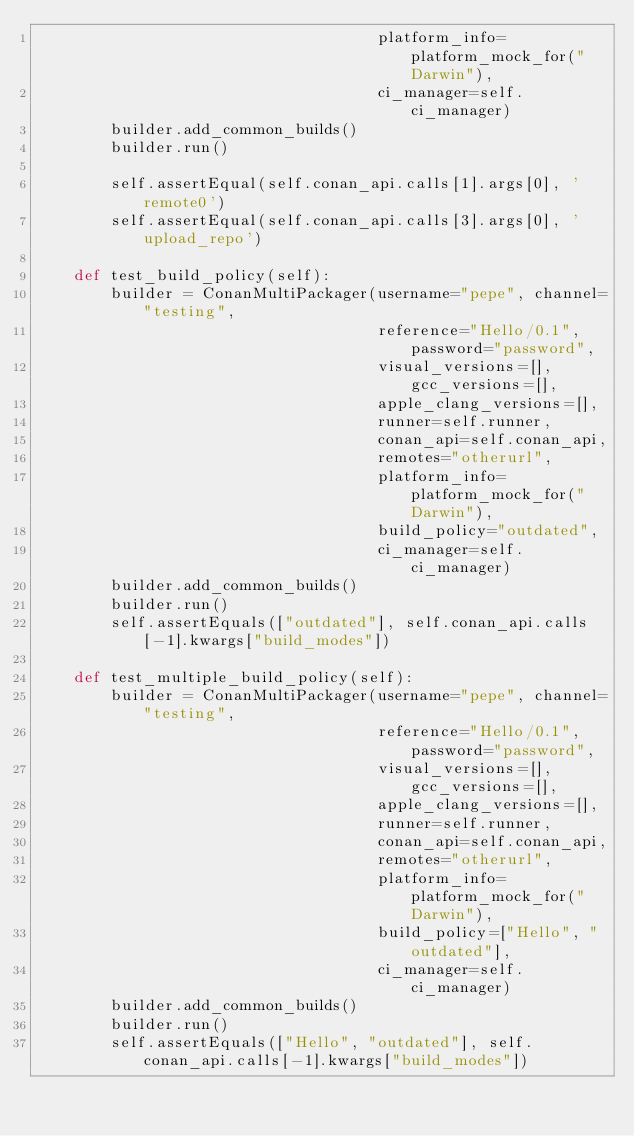<code> <loc_0><loc_0><loc_500><loc_500><_Python_>                                     platform_info=platform_mock_for("Darwin"),
                                     ci_manager=self.ci_manager)
        builder.add_common_builds()
        builder.run()

        self.assertEqual(self.conan_api.calls[1].args[0], 'remote0')
        self.assertEqual(self.conan_api.calls[3].args[0], 'upload_repo')

    def test_build_policy(self):
        builder = ConanMultiPackager(username="pepe", channel="testing",
                                     reference="Hello/0.1", password="password",
                                     visual_versions=[], gcc_versions=[],
                                     apple_clang_versions=[],
                                     runner=self.runner,
                                     conan_api=self.conan_api,
                                     remotes="otherurl",
                                     platform_info=platform_mock_for("Darwin"),
                                     build_policy="outdated",
                                     ci_manager=self.ci_manager)
        builder.add_common_builds()
        builder.run()
        self.assertEquals(["outdated"], self.conan_api.calls[-1].kwargs["build_modes"])

    def test_multiple_build_policy(self):
        builder = ConanMultiPackager(username="pepe", channel="testing",
                                     reference="Hello/0.1", password="password",
                                     visual_versions=[], gcc_versions=[],
                                     apple_clang_versions=[],
                                     runner=self.runner,
                                     conan_api=self.conan_api,
                                     remotes="otherurl",
                                     platform_info=platform_mock_for("Darwin"),
                                     build_policy=["Hello", "outdated"],
                                     ci_manager=self.ci_manager)
        builder.add_common_builds()
        builder.run()
        self.assertEquals(["Hello", "outdated"], self.conan_api.calls[-1].kwargs["build_modes"])

</code> 